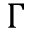<formula> <loc_0><loc_0><loc_500><loc_500>\Gamma</formula> 